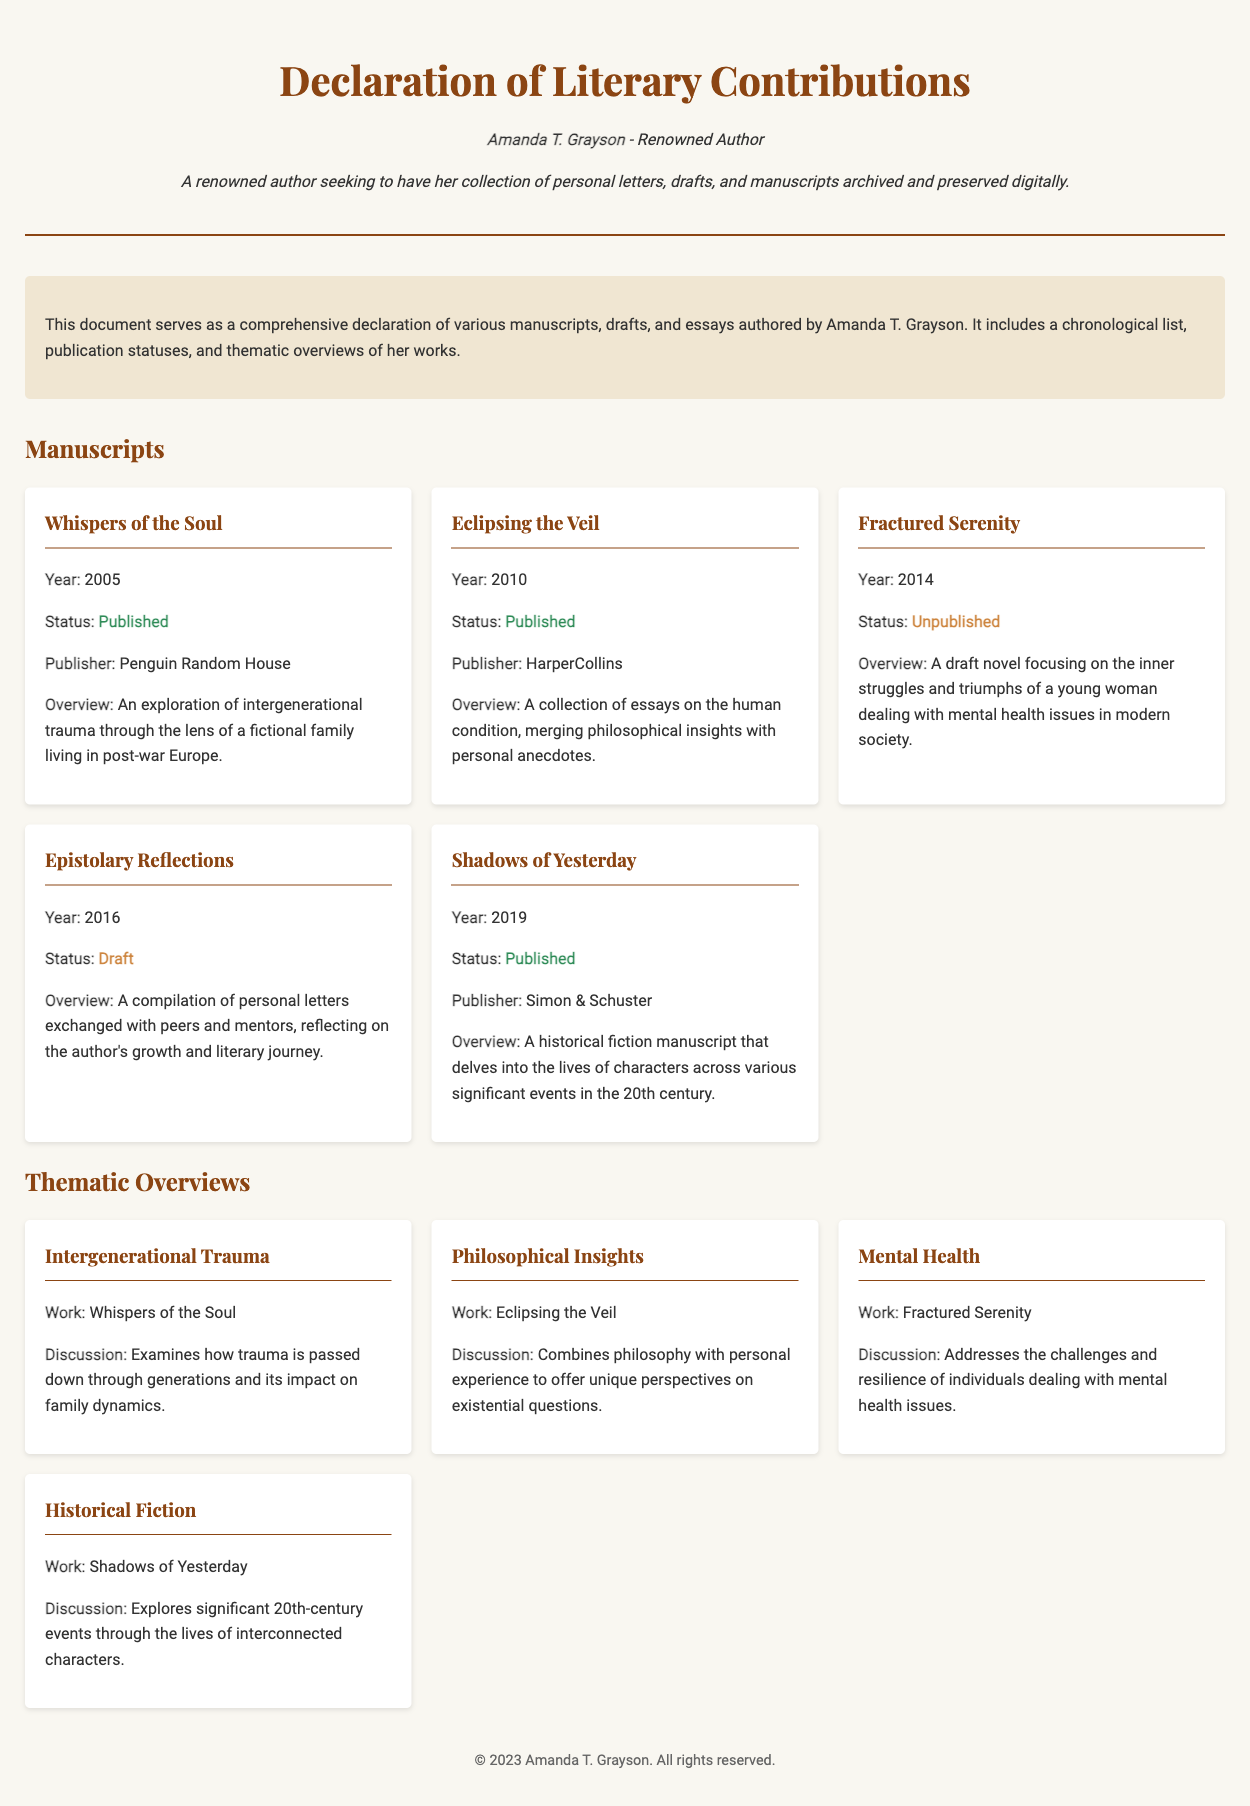What is the title of the first manuscript? The title of the first manuscript listed in the document is "Whispers of the Soul."
Answer: Whispers of the Soul In which year was "Eclipsing the Veil" published? "Eclipsing the Veil" was published in 2010, as indicated in the document.
Answer: 2010 What is the publication status of "Fractured Serenity"? The document states that "Fractured Serenity" is unpublished.
Answer: Unpublished Who is the publisher of "Shadows of Yesterday"? The publisher of "Shadows of Yesterday" is Simon & Schuster, as per the document.
Answer: Simon & Schuster What thematic overview is discussed in relation to "Whispers of the Soul"? The thematic overview related to "Whispers of the Soul" is about intergenerational trauma.
Answer: Intergenerational Trauma How many manuscripts are listed in total? The document lists a total of five manuscripts authored by Amanda T. Grayson.
Answer: Five What is the status of "Epistolary Reflections"? "Epistolary Reflections" is currently in draft status according to the document.
Answer: Draft Which manuscript explores mental health issues? "Fractured Serenity" focuses on mental health issues, as highlighted in the thematic overview.
Answer: Fractured Serenity What type of literary work is "Shadows of Yesterday"? "Shadows of Yesterday" is characterized as a historical fiction manuscript in the document.
Answer: Historical Fiction 